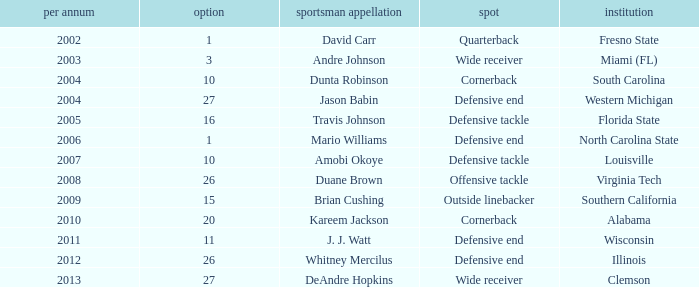What pick was mario williams before 2006? None. 